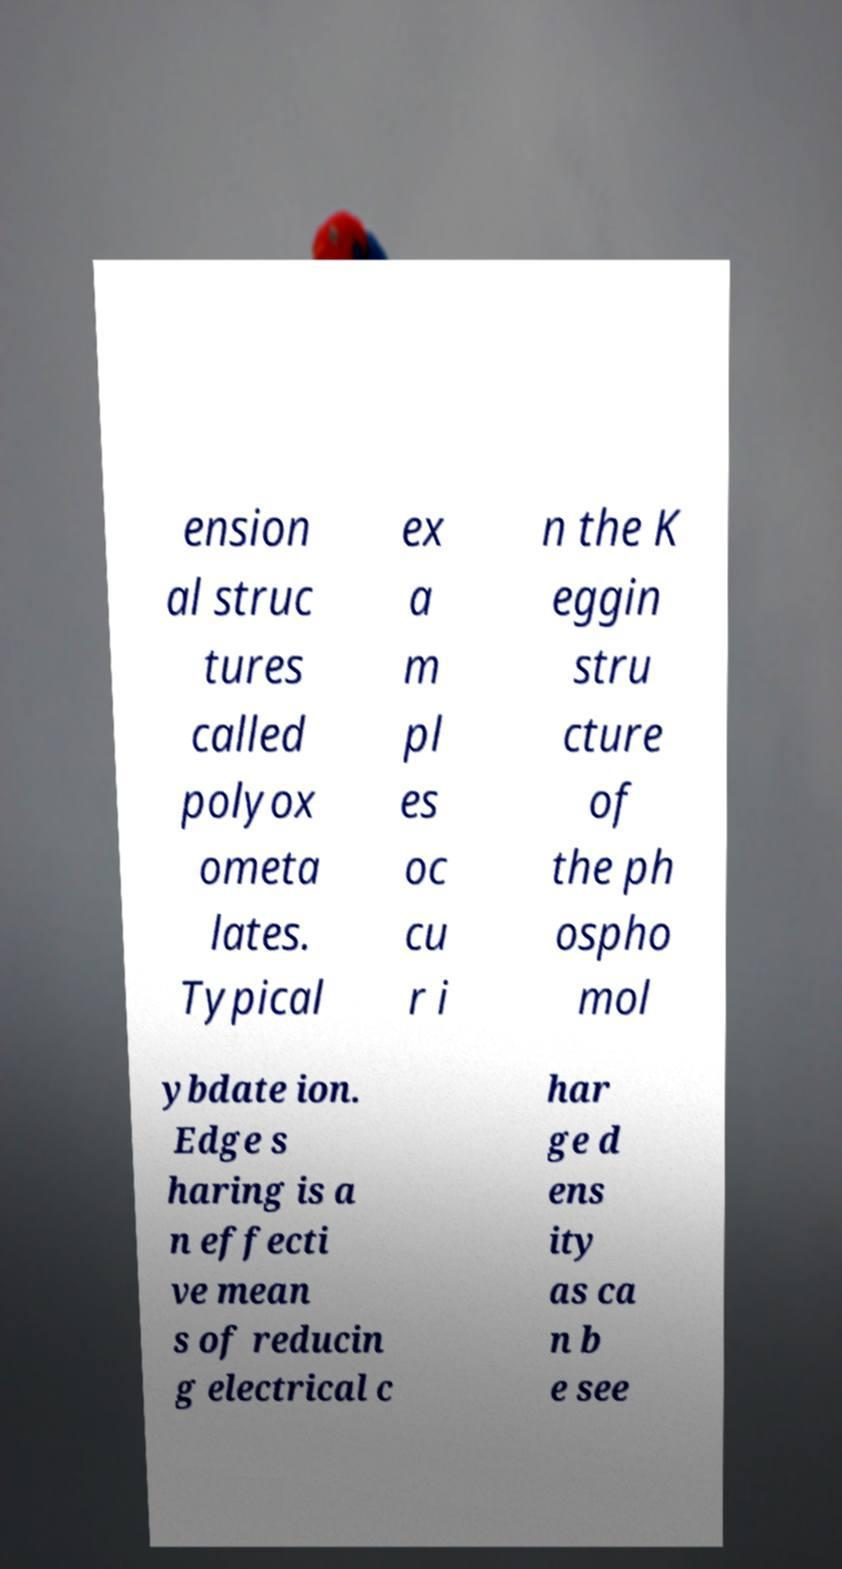Can you accurately transcribe the text from the provided image for me? ension al struc tures called polyox ometa lates. Typical ex a m pl es oc cu r i n the K eggin stru cture of the ph ospho mol ybdate ion. Edge s haring is a n effecti ve mean s of reducin g electrical c har ge d ens ity as ca n b e see 